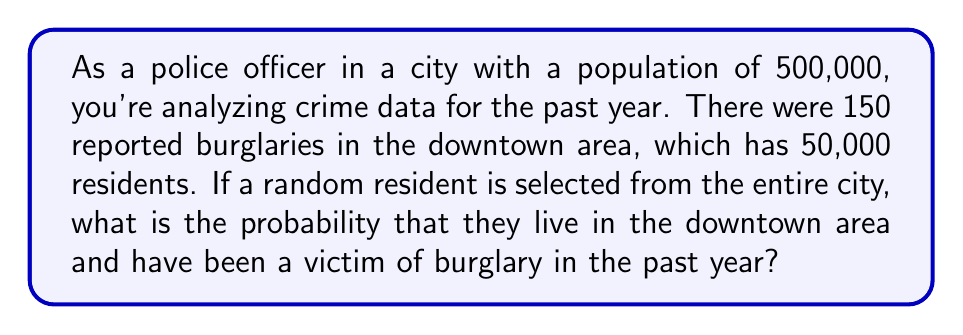Provide a solution to this math problem. To solve this problem, we need to use the concept of conditional probability. Let's break it down step by step:

1. Define events:
   A: The person lives in the downtown area
   B: The person has been a victim of burglary

2. Calculate probabilities:
   P(A) = Probability of living in downtown area
   $P(A) = \frac{50,000}{500,000} = 0.1$

   P(B|A) = Probability of being a burglary victim given that the person lives downtown
   $P(B|A) = \frac{150}{50,000} = 0.003$

3. Use the multiplication rule of probability:
   P(A and B) = P(A) × P(B|A)

4. Substitute the values:
   $P(A \text{ and } B) = 0.1 \times 0.003 = 0.0003$

5. Convert to percentage:
   $0.0003 \times 100\% = 0.03\%$

This means that the probability of randomly selecting a person from the entire city who both lives in the downtown area and has been a victim of burglary in the past year is 0.03% or 3 in 10,000.
Answer: The probability is 0.0003 or 0.03%. 